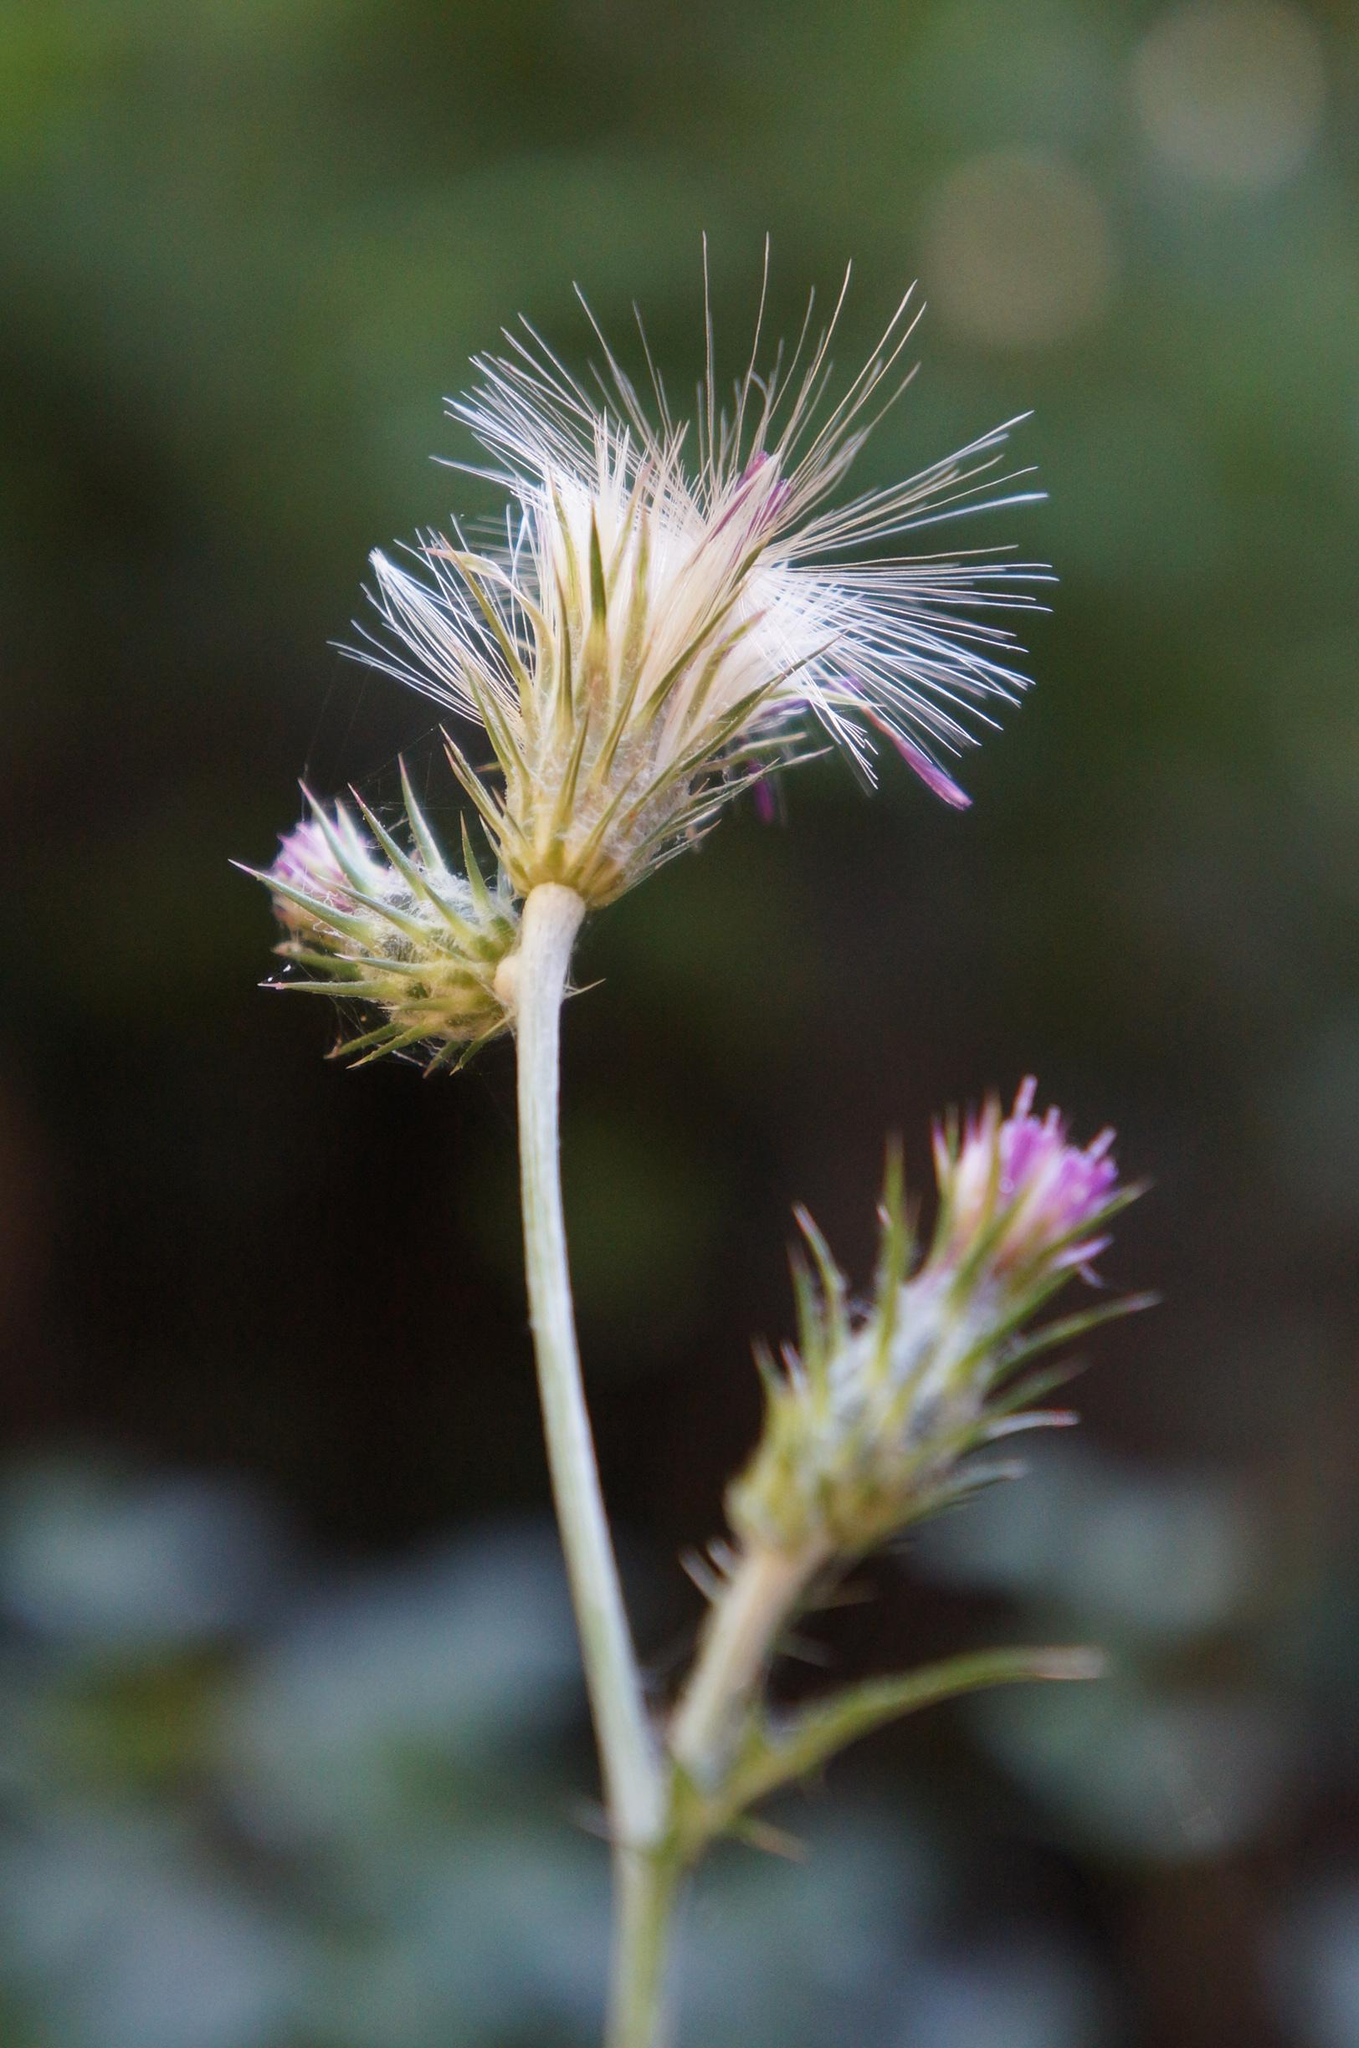What is the main subject of the image? There is a flower in the image. What level of difficulty is the beginner's guide to writing letters in the image? There is no beginner's guide to writing letters present in the image; it features a flower. What type of surprise can be seen in the image? There is no surprise present in the image; it features a flower. 